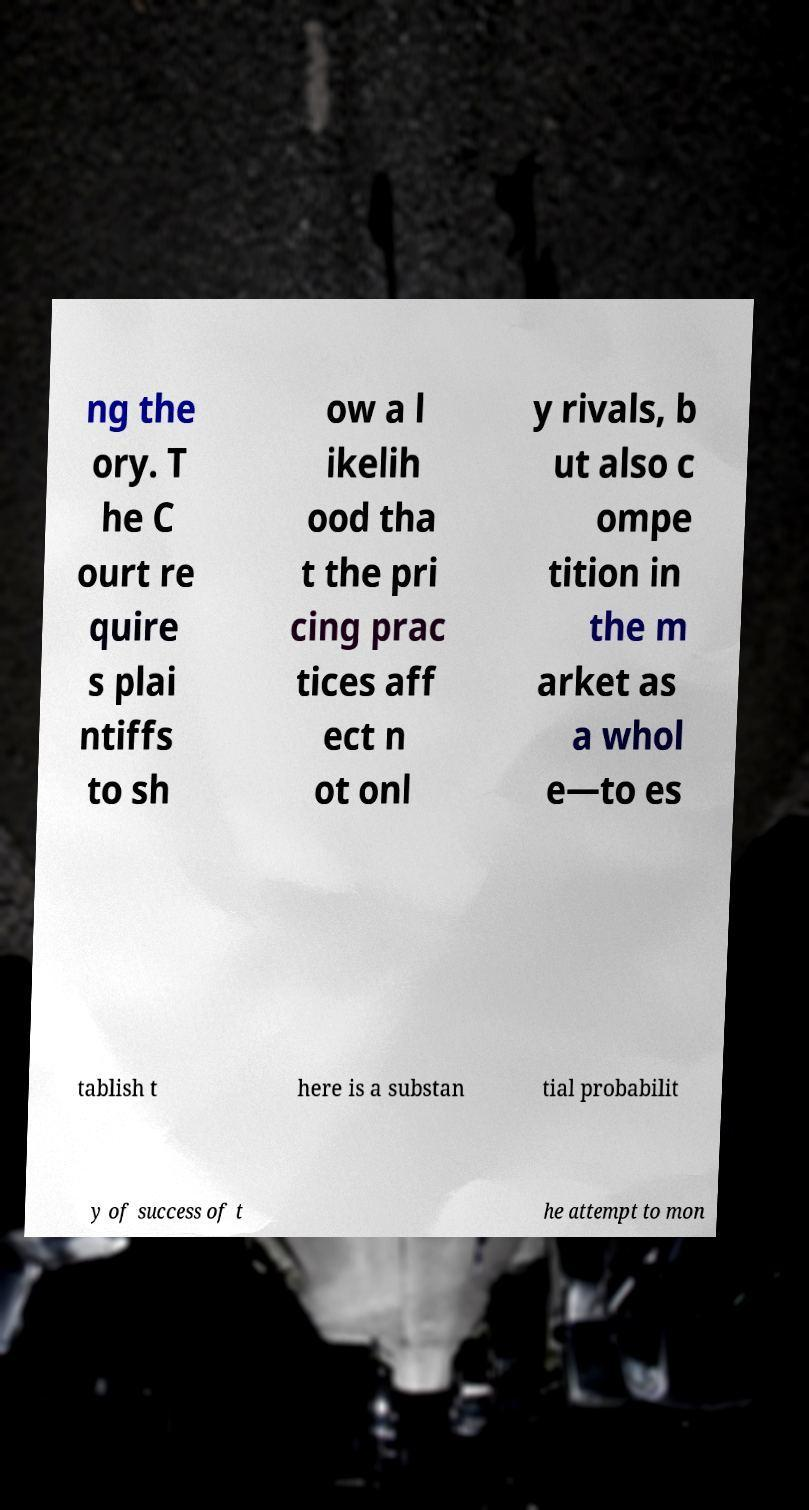Can you read and provide the text displayed in the image?This photo seems to have some interesting text. Can you extract and type it out for me? ng the ory. T he C ourt re quire s plai ntiffs to sh ow a l ikelih ood tha t the pri cing prac tices aff ect n ot onl y rivals, b ut also c ompe tition in the m arket as a whol e—to es tablish t here is a substan tial probabilit y of success of t he attempt to mon 